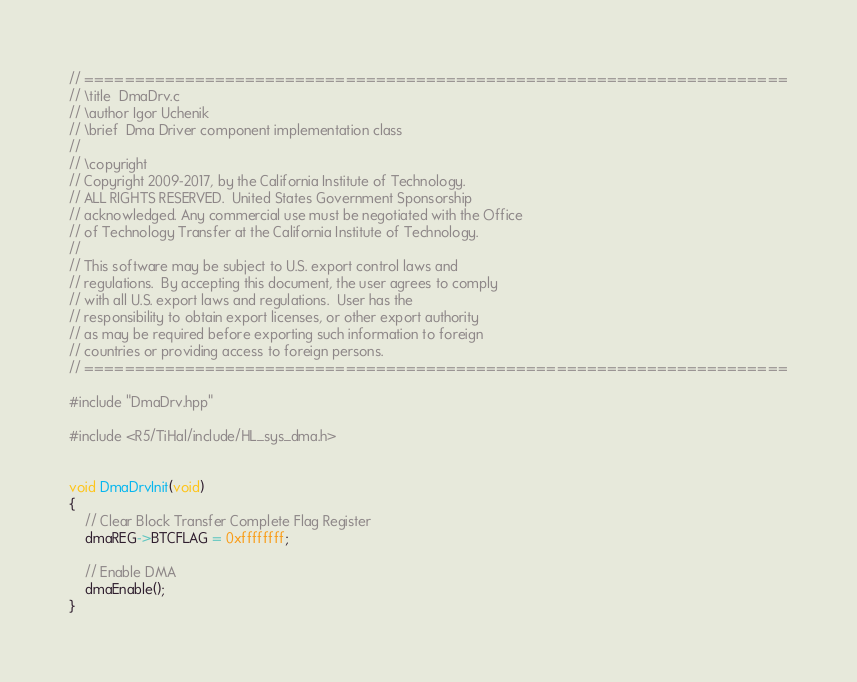Convert code to text. <code><loc_0><loc_0><loc_500><loc_500><_C++_>// ======================================================================
// \title  DmaDrv.c
// \author Igor Uchenik
// \brief  Dma Driver component implementation class
//
// \copyright
// Copyright 2009-2017, by the California Institute of Technology.
// ALL RIGHTS RESERVED.  United States Government Sponsorship
// acknowledged. Any commercial use must be negotiated with the Office
// of Technology Transfer at the California Institute of Technology.
//
// This software may be subject to U.S. export control laws and
// regulations.  By accepting this document, the user agrees to comply
// with all U.S. export laws and regulations.  User has the
// responsibility to obtain export licenses, or other export authority
// as may be required before exporting such information to foreign
// countries or providing access to foreign persons.
// ======================================================================

#include "DmaDrv.hpp"

#include <R5/TiHal/include/HL_sys_dma.h>


void DmaDrvInit(void)
{
    // Clear Block Transfer Complete Flag Register
    dmaREG->BTCFLAG = 0xffffffff;

    // Enable DMA
    dmaEnable();
}
</code> 